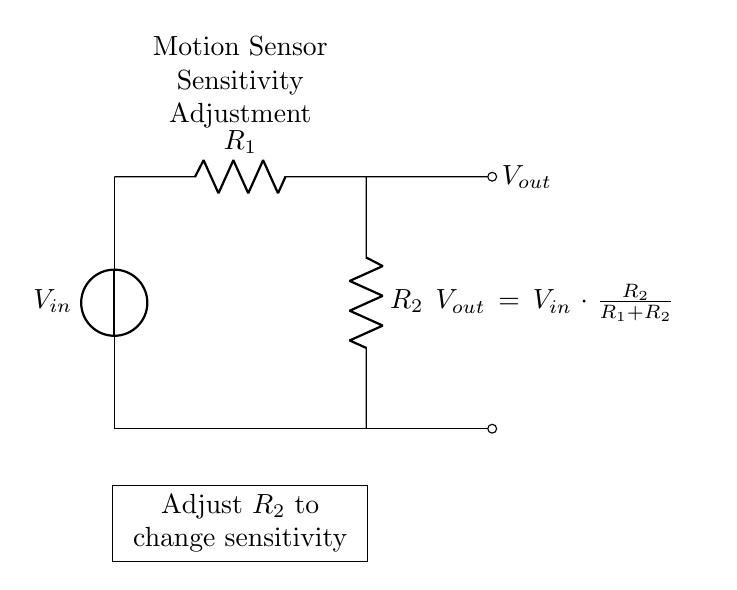what are the components in the circuit? The circuit includes a voltage source, two resistors, and a motion sensor.
Answer: voltage source, resistors, motion sensor what is the formula for Vout in this circuit? The output voltage is calculated using the formula \( V_{out} = V_{in} \cdot \frac{R_2}{R_1 + R_2} \), which is given in the circuit.
Answer: Vout = Vin * (R2 / (R1 + R2)) what happens to Vout if R2 is increased? Increasing R2 increases the fraction of Vout because the resistance ratio changes, leading to a higher output voltage.
Answer: Vout increases how does adjusting R2 affect the motion sensor sensitivity? Adjusting R2 modifies the output voltage applied to the motion sensor, which directly influences its sensitivity to motion detection.
Answer: It changes sensitivity what is the role of R1 in the voltage divider? R1 helps to form the voltage divider by affecting the total resistance and thus the output voltage when combined with R2.
Answer: It limits output voltage if Vin is 12 volts and R1 is 1000 ohms while R2 is 2000 ohms, what is Vout? Using the voltage divider formula, \( V_{out} = 12V \cdot \frac{2000}{1000 + 2000} = 12V \cdot \frac{2}{3} = 8V \).
Answer: 8 volts 